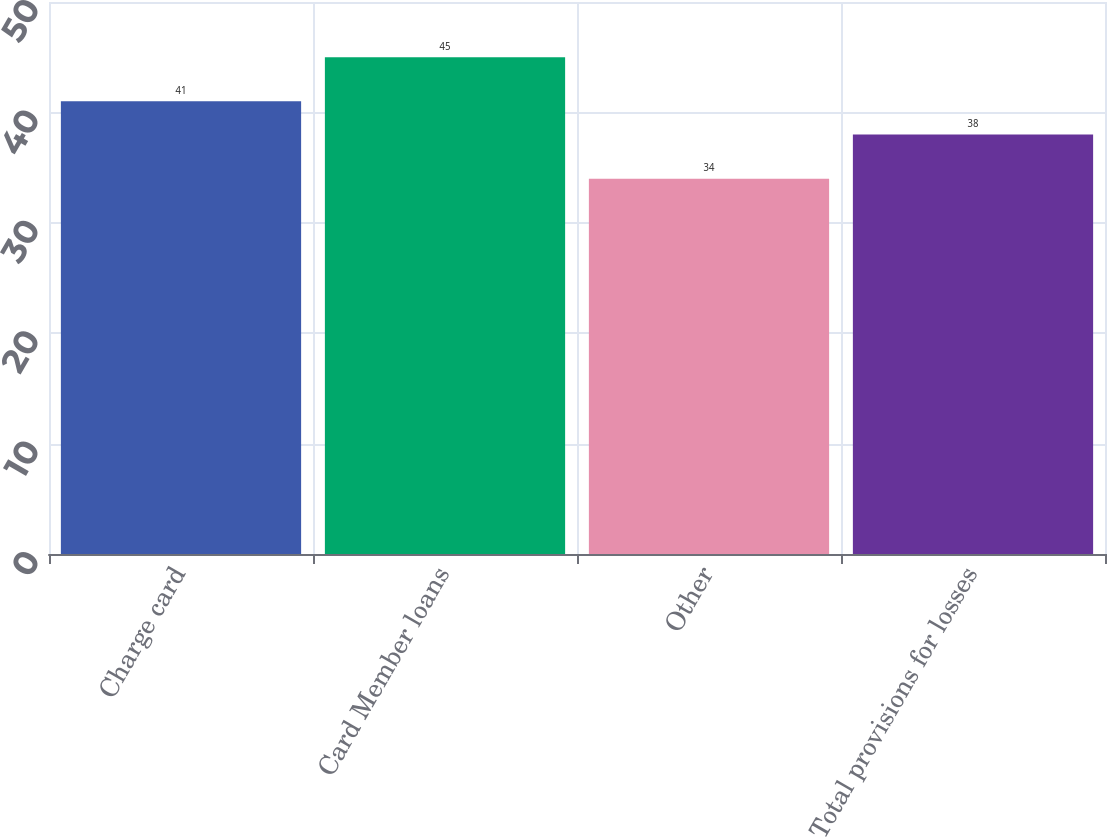Convert chart. <chart><loc_0><loc_0><loc_500><loc_500><bar_chart><fcel>Charge card<fcel>Card Member loans<fcel>Other<fcel>Total provisions for losses<nl><fcel>41<fcel>45<fcel>34<fcel>38<nl></chart> 